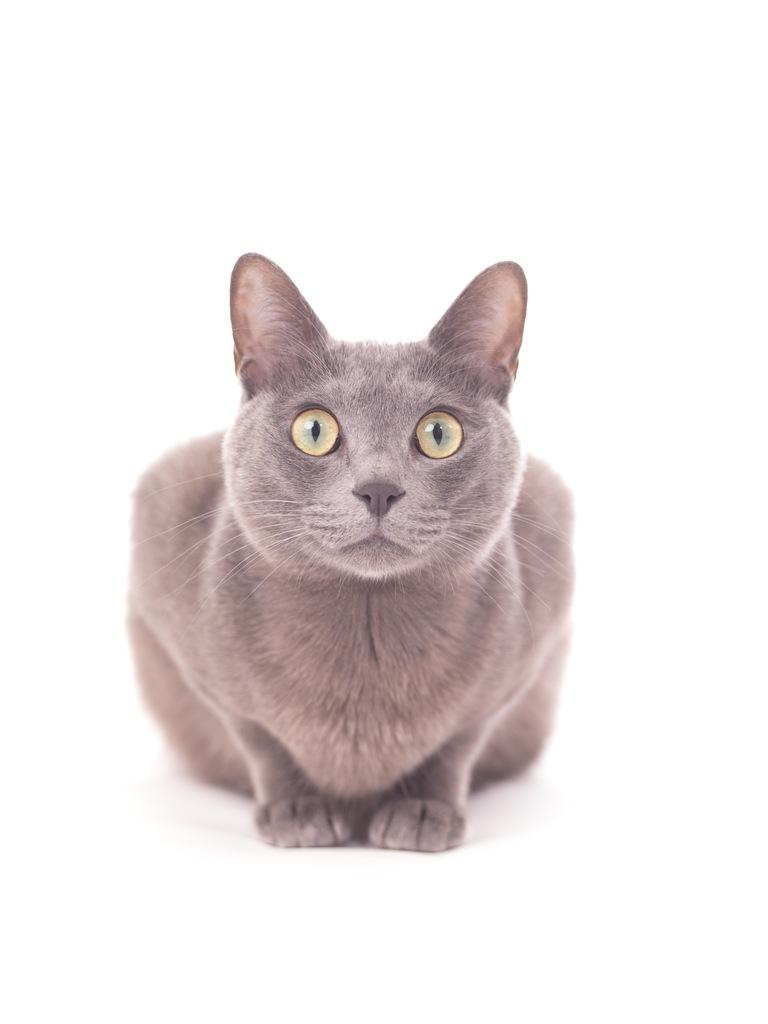What animal is present in the image? There is a cat in the image. What is the cat doing in the image? The cat is sitting. What color is the background of the image? The background of the image is white in color. What type of zephyr can be seen blowing through the cat's fur in the image? There is no zephyr present in the image, and the cat's fur is not being blown by any wind. 